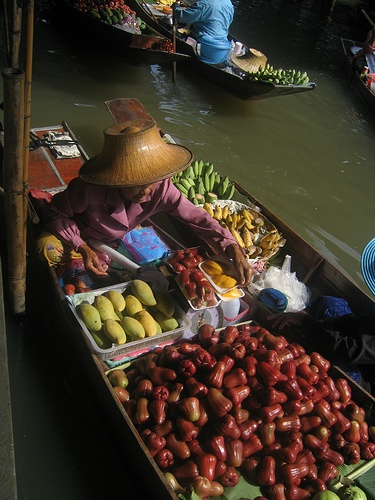Describe the objects in this image and their specific colors. I can see boat in black, maroon, olive, and brown tones, people in black, brown, maroon, and olive tones, boat in black, maroon, and gray tones, boat in black and gray tones, and people in black, lightblue, blue, and gray tones in this image. 